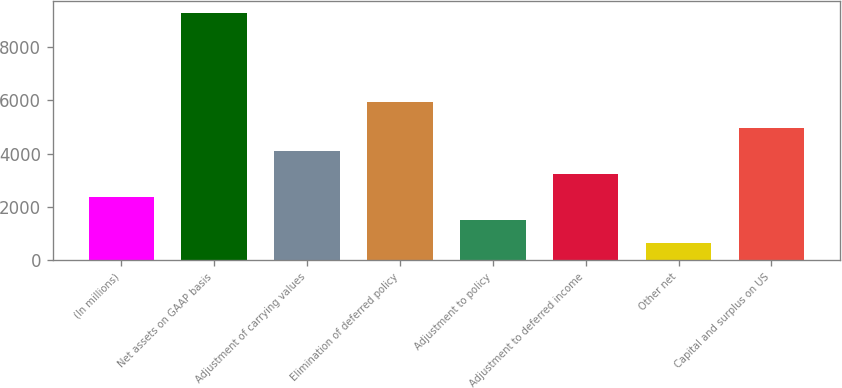Convert chart. <chart><loc_0><loc_0><loc_500><loc_500><bar_chart><fcel>(In millions)<fcel>Net assets on GAAP basis<fcel>Adjustment of carrying values<fcel>Elimination of deferred policy<fcel>Adjustment to policy<fcel>Adjustment to deferred income<fcel>Other net<fcel>Capital and surplus on US<nl><fcel>2387.1<fcel>9266<fcel>4109.3<fcel>5922<fcel>1526<fcel>3248.2<fcel>655<fcel>4970.4<nl></chart> 